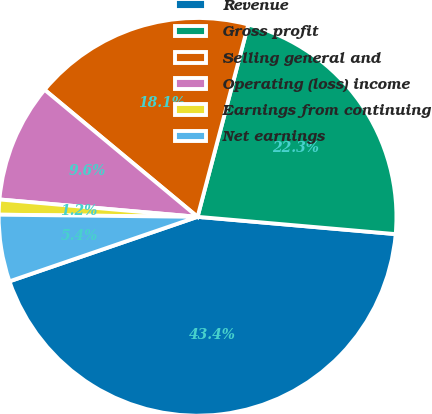Convert chart to OTSL. <chart><loc_0><loc_0><loc_500><loc_500><pie_chart><fcel>Revenue<fcel>Gross profit<fcel>Selling general and<fcel>Operating (loss) income<fcel>Earnings from continuing<fcel>Net earnings<nl><fcel>43.35%<fcel>22.28%<fcel>18.07%<fcel>9.64%<fcel>1.22%<fcel>5.43%<nl></chart> 